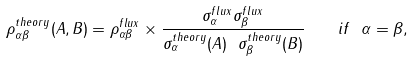Convert formula to latex. <formula><loc_0><loc_0><loc_500><loc_500>\rho _ { \alpha \beta } ^ { t h e o r y } ( A , B ) = \rho _ { \alpha \beta } ^ { f l u x } \times \frac { \sigma _ { \alpha } ^ { f l u x } \sigma _ { \beta } ^ { f l u x } } { \sigma _ { \alpha } ^ { t h e o r y } ( A ) \ \sigma _ { \beta } ^ { t h e o r y } ( B ) } \quad i f \ \alpha = \beta ,</formula> 